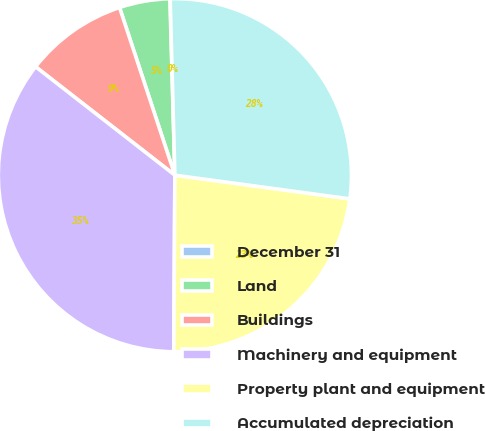<chart> <loc_0><loc_0><loc_500><loc_500><pie_chart><fcel>December 31<fcel>Land<fcel>Buildings<fcel>Machinery and equipment<fcel>Property plant and equipment<fcel>Accumulated depreciation<nl><fcel>0.03%<fcel>4.62%<fcel>9.4%<fcel>35.43%<fcel>22.96%<fcel>27.56%<nl></chart> 